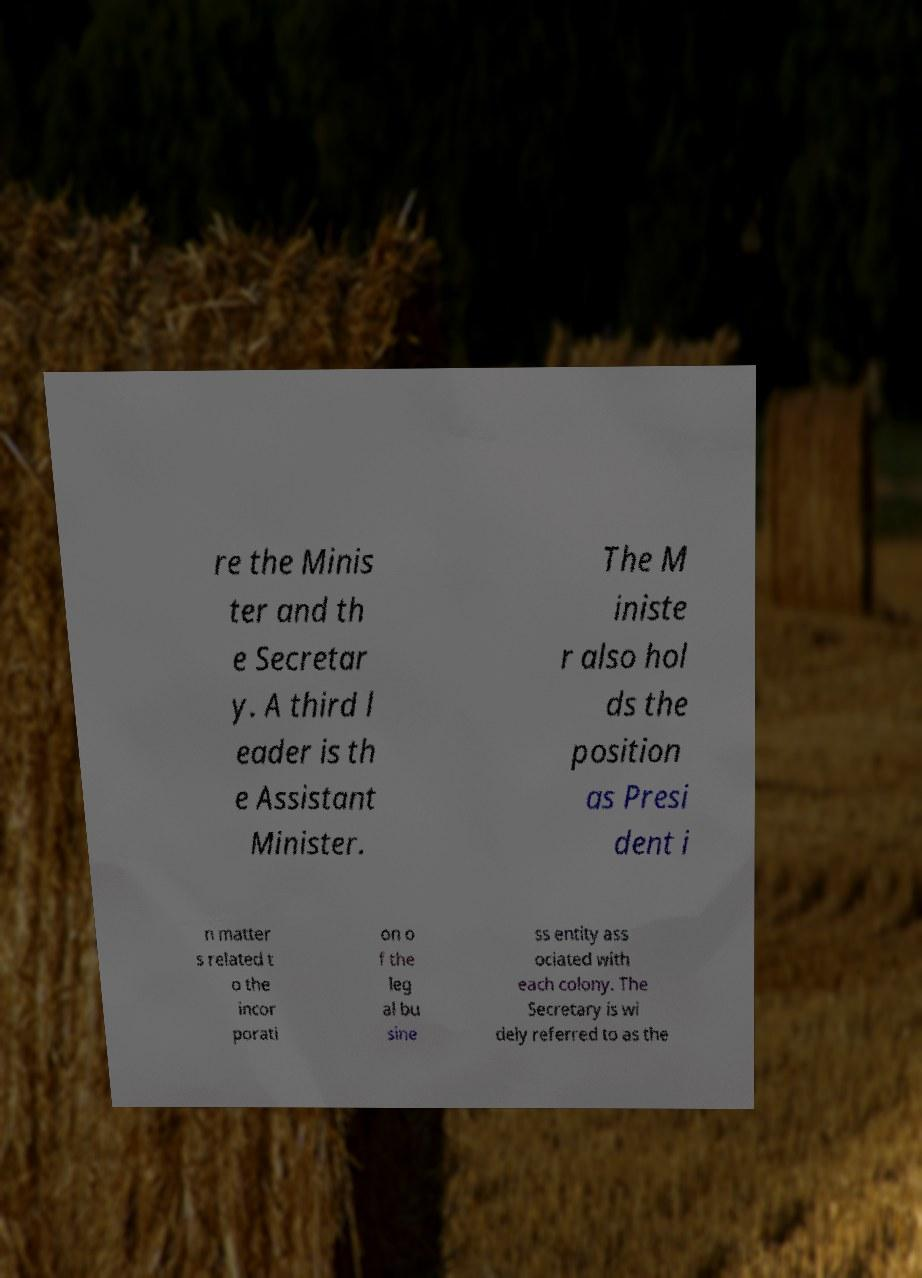For documentation purposes, I need the text within this image transcribed. Could you provide that? re the Minis ter and th e Secretar y. A third l eader is th e Assistant Minister. The M iniste r also hol ds the position as Presi dent i n matter s related t o the incor porati on o f the leg al bu sine ss entity ass ociated with each colony. The Secretary is wi dely referred to as the 